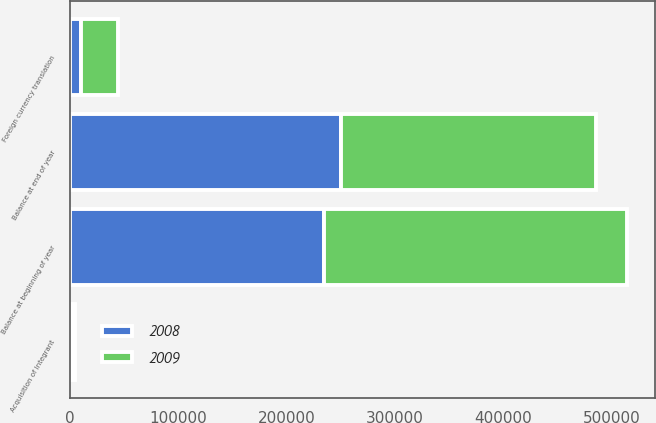Convert chart to OTSL. <chart><loc_0><loc_0><loc_500><loc_500><stacked_bar_chart><ecel><fcel>Balance at beginning of year<fcel>Acquisition of Integrant<fcel>Foreign currency translation<fcel>Balance at end of year<nl><fcel>2008<fcel>235175<fcel>2098<fcel>10537<fcel>250881<nl><fcel>2009<fcel>279469<fcel>2988<fcel>34633<fcel>235175<nl></chart> 